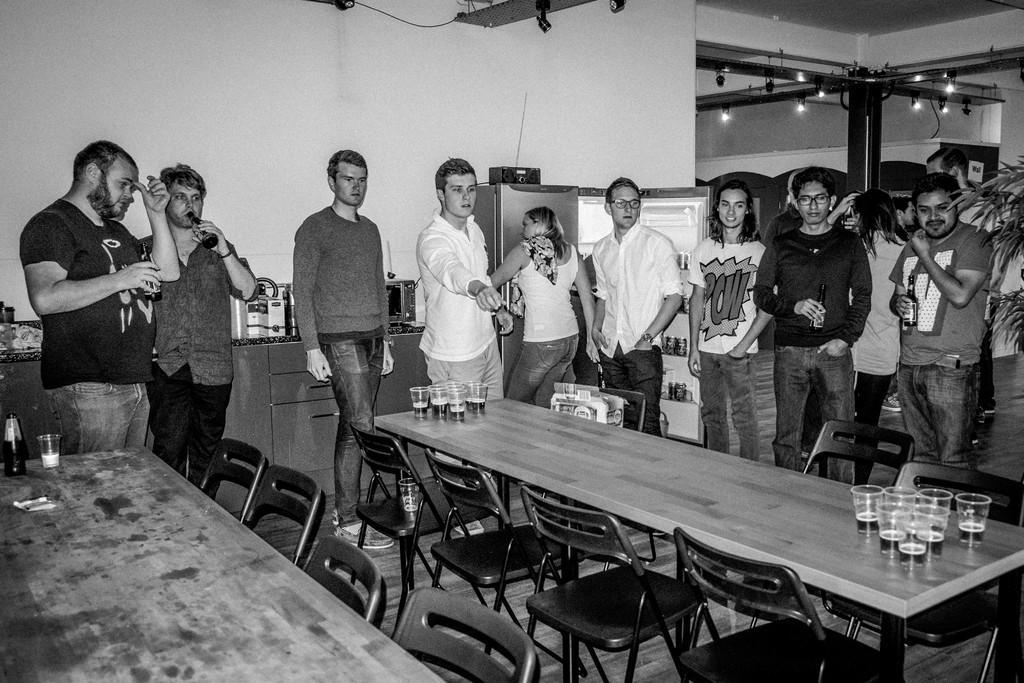Can you describe this image briefly? In this image there is a room where in the right side there are some group of people standing and at the left side there are some group of people standing and in the middle there is a table which contains of some glasses and some chairs and at the back ground there is a fridge and a radio up of the refrigerator and there are some focus lights attached to the poles. 